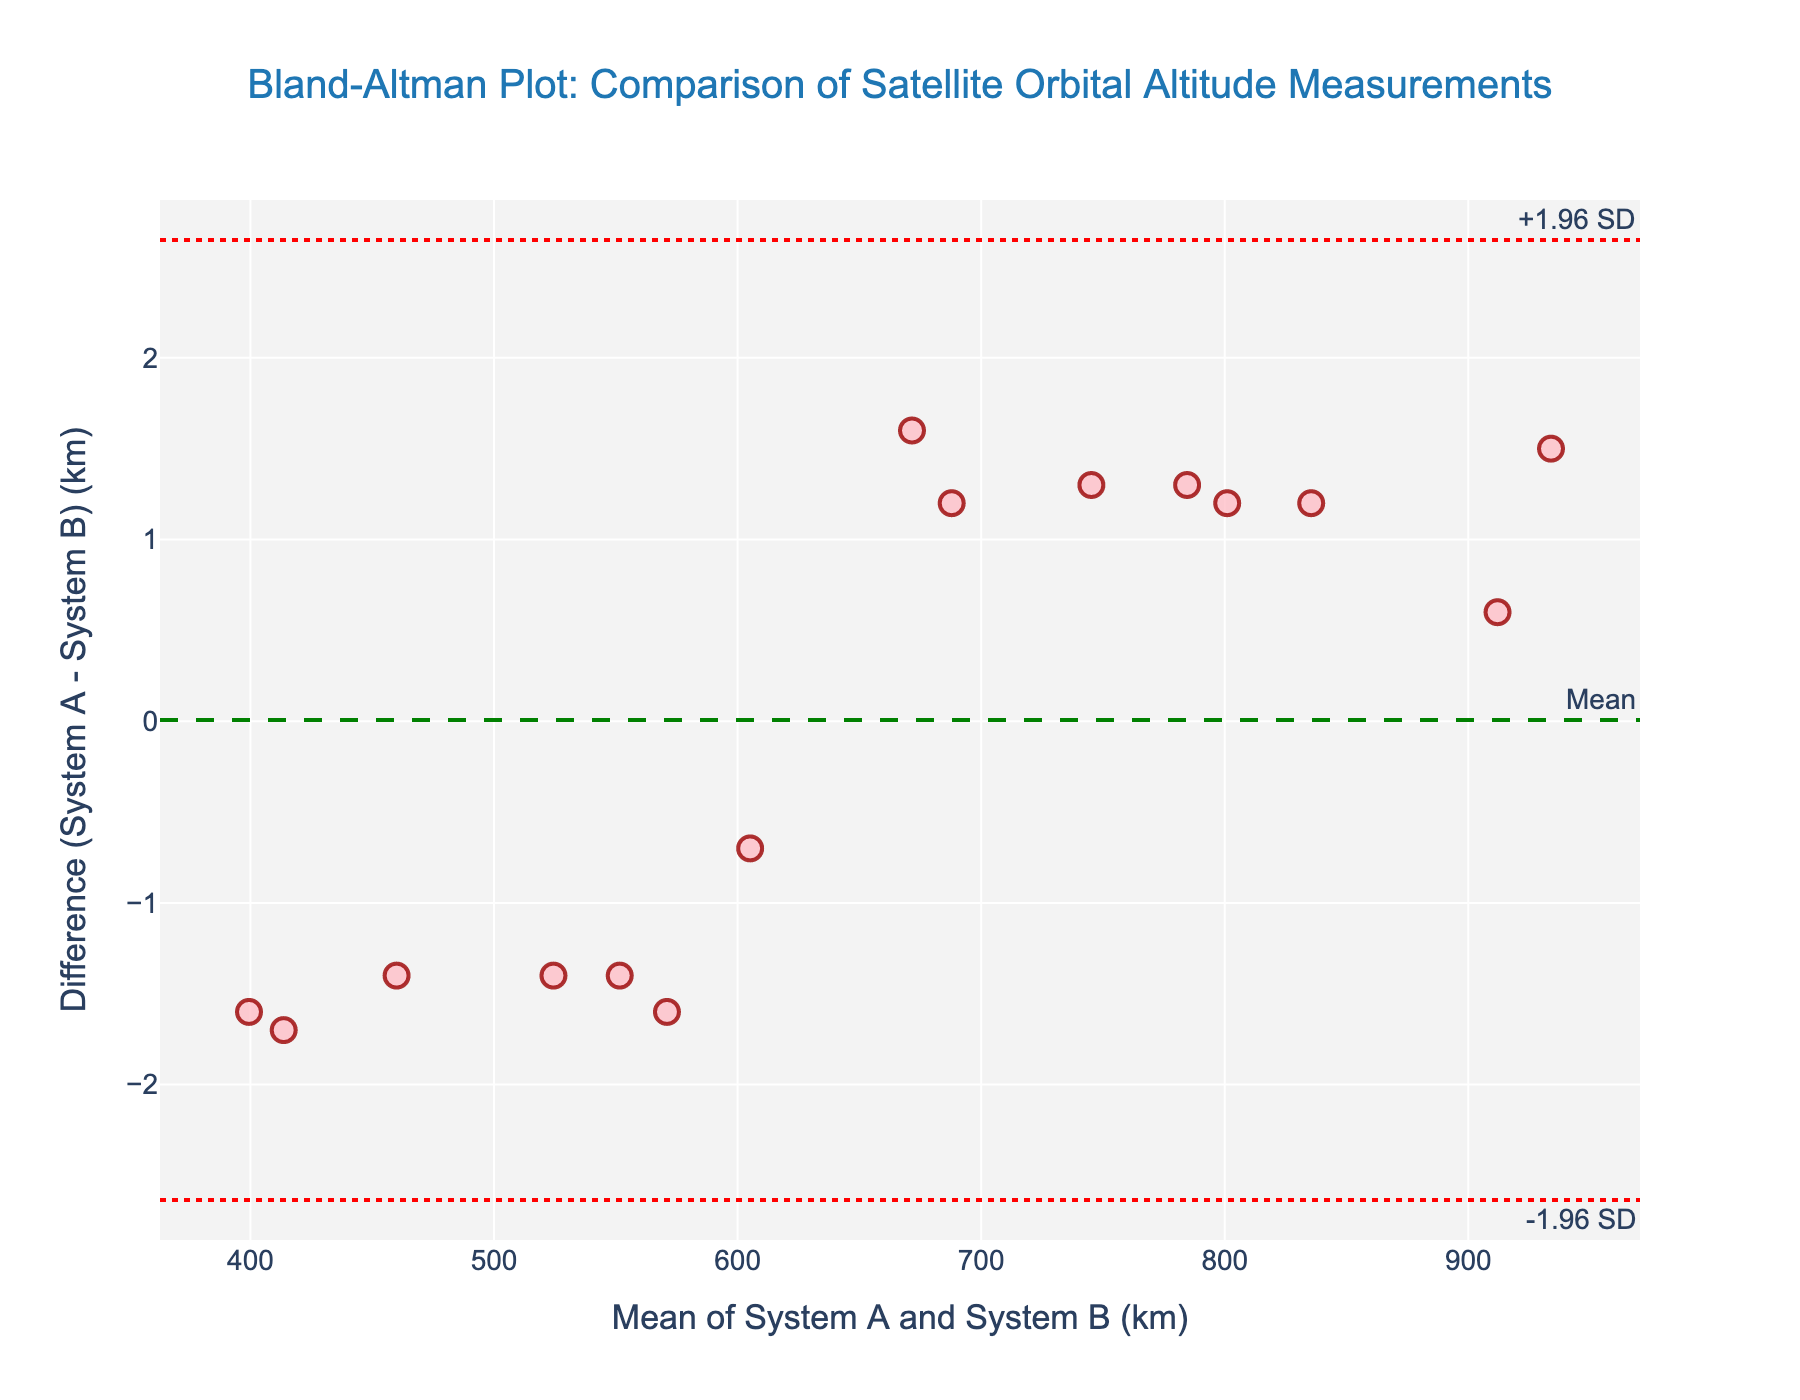What's the difference between the highest and lowest mean values on the x-axis? The highest mean value is calculated from the point where the average of System A and System B is the largest, which appears to be around 923.0 km. The lowest mean value is where the average is the smallest, around 399.4 km. The difference is 923.0 - 399.4.
Answer: 523.6 km How many data points lie above the mean difference line? By visually inspecting the plot, count the number of data points that are positioned above the green mean difference line.
Answer: 7 data points What is the approximate mean difference between the two systems? The green dashed line represents the mean difference, which appears to be slightly below zero but very close to it.
Answer: Approximately -0.1 km What are the upper and lower limits of agreement in the plot? The red dotted lines represent the limits of agreement. The upper limit is labeled "+1.96 SD" and appears to be around 1.5 km. The lower limit is labeled "-1.96 SD" and appears to be around -1.7 km.
Answer: Approximately 1.5 km and -1.7 km Is the variance between the two systems' measurements consistent across different mean values? By examining the scatter of data points, one can determine if the differences are evenly distributed along the y-axis or if they vary. The plot shows relatively consistent spread with no clear pattern indicating varying variance.
Answer: Yes, the variance appears consistent Which system generally reports higher altitudes when there are discrepancies? By looking at the direction of the differences (System A - System B), most points are slightly above or below zero, but there are more negative differences, indicating that System B generally reports higher altitudes.
Answer: System B What is the highest measured altitude from System A in the data? The plot’s x-axis shows the mean values from both systems. The highest mean value around 923.0 km relates to System A measuring even higher. By matching this with the data values provided, System A has the highest measured altitude of 934.7 km.
Answer: 934.7 km Where are the measurements most clustered on the plot? By looking for the densest concentration of points along the x-axis. Most points seem clustered around the mean values between 500 km to 750 km.
Answer: Between 500 km to 750 km How can you tell whether the two systems provide measurements that are systematically biased? The mean difference (green line) shows whether one system consistently reports higher or lower values. Since the mean difference is close to zero, there doesn't appear to be significant systematic bias.
Answer: There is no significant systematic bias 